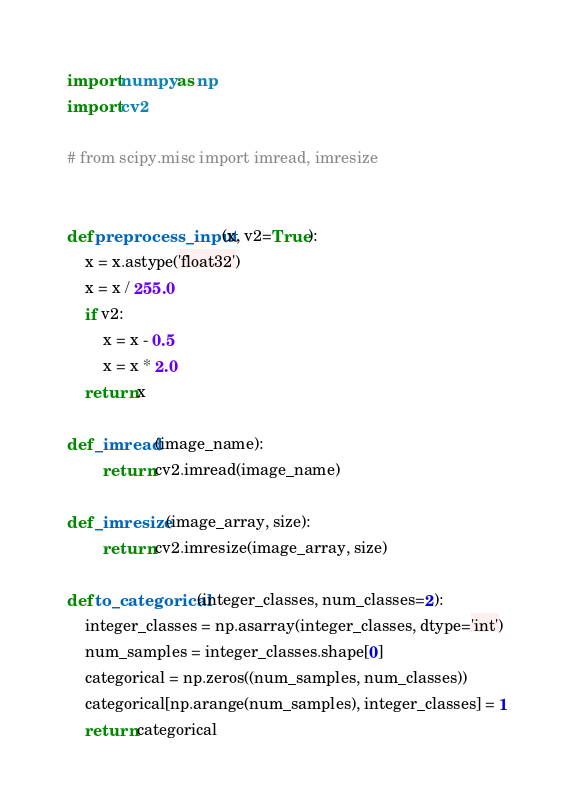<code> <loc_0><loc_0><loc_500><loc_500><_Python_>import numpy as np
import cv2

# from scipy.misc import imread, imresize


def preprocess_input(x, v2=True):
    x = x.astype('float32')
    x = x / 255.0
    if v2:
        x = x - 0.5
        x = x * 2.0
    return x

def _imread(image_name):
        return cv2.imread(image_name)

def _imresize(image_array, size):
        return cv2.imresize(image_array, size)

def to_categorical(integer_classes, num_classes=2):
    integer_classes = np.asarray(integer_classes, dtype='int')
    num_samples = integer_classes.shape[0]
    categorical = np.zeros((num_samples, num_classes))
    categorical[np.arange(num_samples), integer_classes] = 1
    return categorical

</code> 